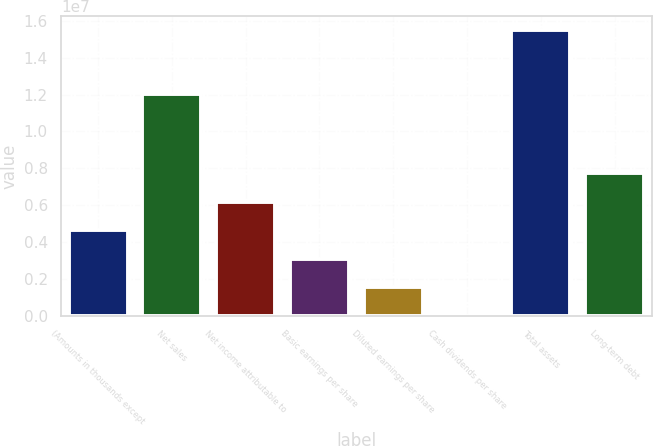<chart> <loc_0><loc_0><loc_500><loc_500><bar_chart><fcel>(Amounts in thousands except<fcel>Net sales<fcel>Net income attributable to<fcel>Basic earnings per share<fcel>Diluted earnings per share<fcel>Cash dividends per share<fcel>Total assets<fcel>Long-term debt<nl><fcel>4.64697e+06<fcel>1.20293e+07<fcel>6.19596e+06<fcel>3.09798e+06<fcel>1.54899e+06<fcel>2.58<fcel>1.54899e+07<fcel>7.74495e+06<nl></chart> 